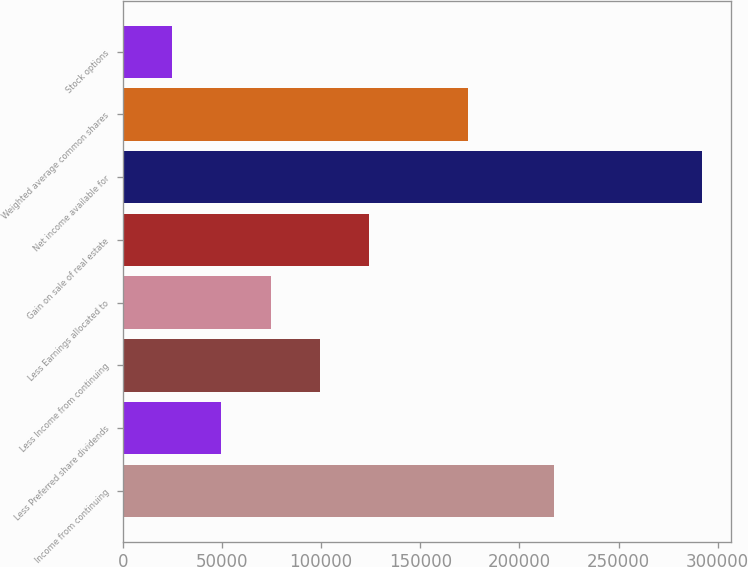<chart> <loc_0><loc_0><loc_500><loc_500><bar_chart><fcel>Income from continuing<fcel>Less Preferred share dividends<fcel>Less Income from continuing<fcel>Less Earnings allocated to<fcel>Gain on sale of real estate<fcel>Net income available for<fcel>Weighted average common shares<fcel>Stock options<nl><fcel>217534<fcel>49736.2<fcel>99468.9<fcel>74602.6<fcel>124335<fcel>292133<fcel>174068<fcel>24869.9<nl></chart> 